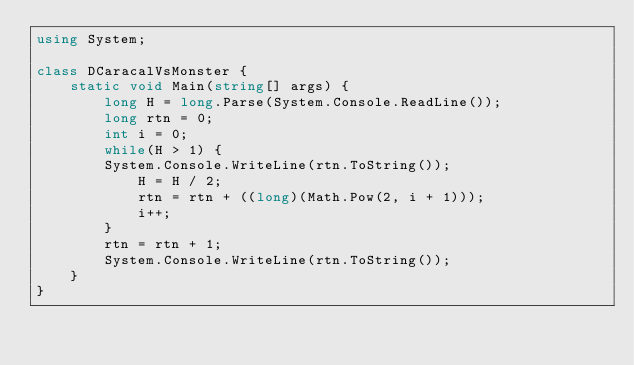Convert code to text. <code><loc_0><loc_0><loc_500><loc_500><_C#_>using System;

class DCaracalVsMonster {
    static void Main(string[] args) {
        long H = long.Parse(System.Console.ReadLine());
        long rtn = 0;
        int i = 0;
        while(H > 1) {
        System.Console.WriteLine(rtn.ToString());
            H = H / 2;
            rtn = rtn + ((long)(Math.Pow(2, i + 1)));
            i++;
        }
        rtn = rtn + 1;
        System.Console.WriteLine(rtn.ToString());
    }
}
</code> 